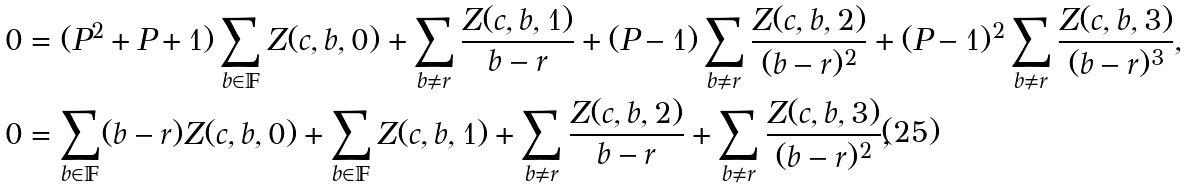<formula> <loc_0><loc_0><loc_500><loc_500>0 & = ( P ^ { 2 } + P + 1 ) \sum _ { b \in \mathbb { F } } Z ( c , b , 0 ) + \sum _ { b \ne r } \frac { Z ( c , b , 1 ) } { b - r } + ( P - 1 ) \sum _ { b \ne r } \frac { Z ( c , b , 2 ) } { ( b - r ) ^ { 2 } } + ( P - 1 ) ^ { 2 } \sum _ { b \ne r } \frac { Z ( c , b , 3 ) } { ( b - r ) ^ { 3 } } , \\ 0 & = \sum _ { b \in \mathbb { F } } ( b - r ) Z ( c , b , 0 ) + \sum _ { b \in \mathbb { F } } Z ( c , b , 1 ) + \sum _ { b \ne r } \frac { Z ( c , b , 2 ) } { b - r } + \sum _ { b \ne r } \frac { Z ( c , b , 3 ) } { ( b - r ) ^ { 2 } } ,</formula> 